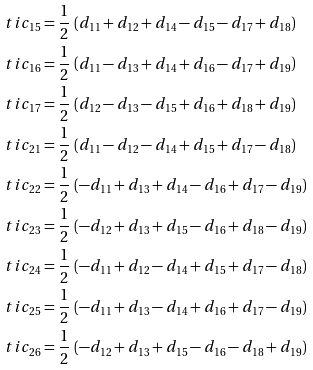Convert formula to latex. <formula><loc_0><loc_0><loc_500><loc_500>\ t i { c } _ { 1 5 } = & \ \frac { 1 } { 2 } \, \left ( d _ { 1 1 } + d _ { 1 2 } + d _ { 1 4 } - d _ { 1 5 } - d _ { 1 7 } + d _ { 1 8 } \right ) \\ \ t i { c } _ { 1 6 } = & \ \frac { 1 } { 2 } \, \left ( d _ { 1 1 } - d _ { 1 3 } + d _ { 1 4 } + d _ { 1 6 } - d _ { 1 7 } + d _ { 1 9 } \right ) \\ \ t i { c } _ { 1 7 } = & \ \frac { 1 } { 2 } \, \left ( d _ { 1 2 } - d _ { 1 3 } - d _ { 1 5 } + d _ { 1 6 } + d _ { 1 8 } + d _ { 1 9 } \right ) \\ \ t i { c } _ { 2 1 } = & \ \frac { 1 } { 2 } \, \left ( d _ { 1 1 } - d _ { 1 2 } - d _ { 1 4 } + d _ { 1 5 } + d _ { 1 7 } - d _ { 1 8 } \right ) \\ \ t i { c } _ { 2 2 } = & \ \frac { 1 } { 2 } \, \left ( - d _ { 1 1 } + d _ { 1 3 } + d _ { 1 4 } - d _ { 1 6 } + d _ { 1 7 } - d _ { 1 9 } \right ) \\ \ t i { c } _ { 2 3 } = & \ \frac { 1 } { 2 } \, \left ( - d _ { 1 2 } + d _ { 1 3 } + d _ { 1 5 } - d _ { 1 6 } + d _ { 1 8 } - d _ { 1 9 } \right ) \\ \ t i { c } _ { 2 4 } = & \ \frac { 1 } { 2 } \, \left ( - d _ { 1 1 } + d _ { 1 2 } - d _ { 1 4 } + d _ { 1 5 } + d _ { 1 7 } - d _ { 1 8 } \right ) \\ \ t i { c } _ { 2 5 } = & \ \frac { 1 } { 2 } \, \left ( - d _ { 1 1 } + d _ { 1 3 } - d _ { 1 4 } + d _ { 1 6 } + d _ { 1 7 } - d _ { 1 9 } \right ) \\ \ t i { c } _ { 2 6 } = & \ \frac { 1 } { 2 } \, \left ( - d _ { 1 2 } + d _ { 1 3 } + d _ { 1 5 } - d _ { 1 6 } - d _ { 1 8 } + d _ { 1 9 } \right )</formula> 